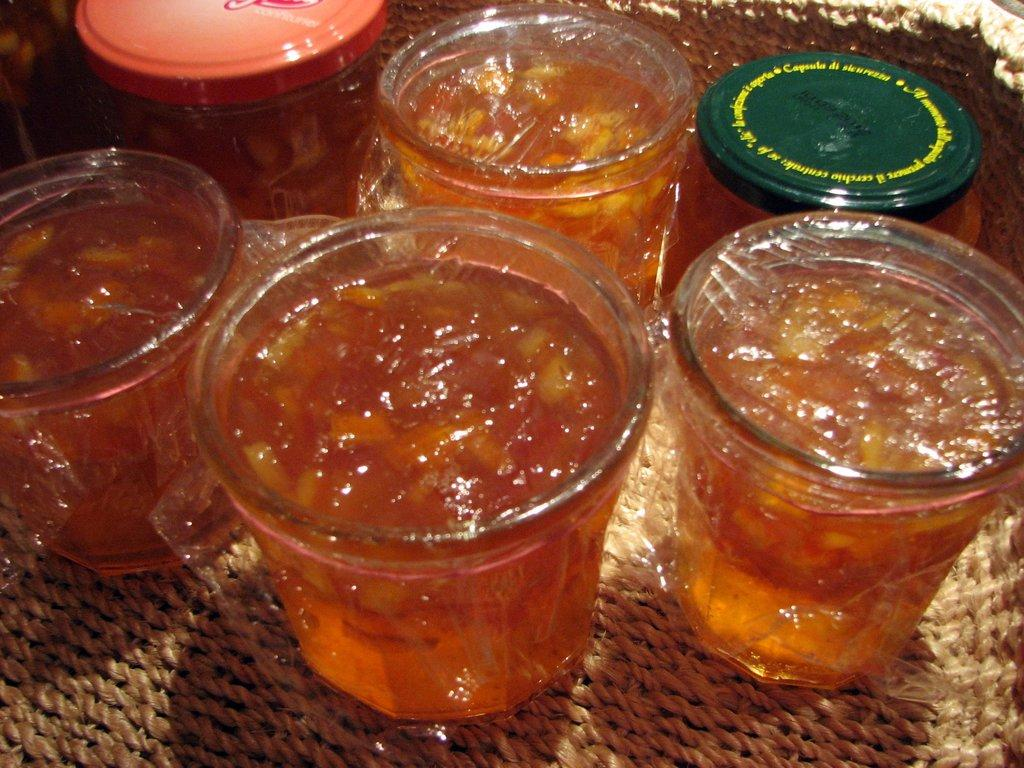What color are the sweets in the image? The sweets in the image are brown in color. How are the sweets arranged or contained in the image? The sweets are in glasses. What is the sweets and glasses placed on in the image? The glasses containing sweets are placed on a jute tray. What type of silk fabric is draped over the sweets in the image? There is no silk fabric present in the image; the sweets are in glasses placed on a jute tray. 